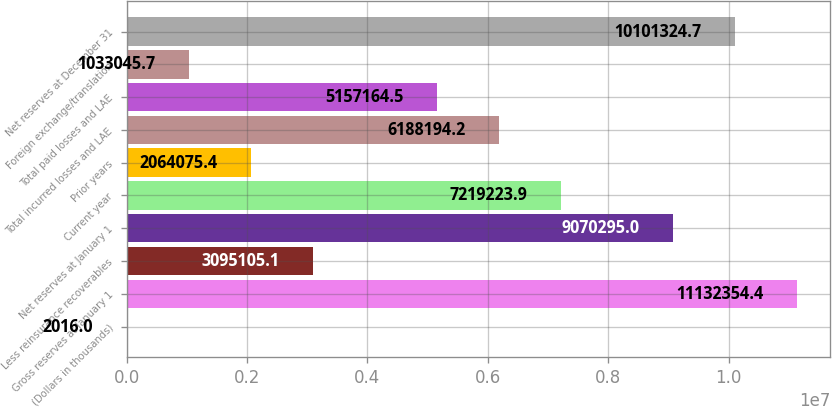Convert chart to OTSL. <chart><loc_0><loc_0><loc_500><loc_500><bar_chart><fcel>(Dollars in thousands)<fcel>Gross reserves at January 1<fcel>Less reinsurance recoverables<fcel>Net reserves at January 1<fcel>Current year<fcel>Prior years<fcel>Total incurred losses and LAE<fcel>Total paid losses and LAE<fcel>Foreign exchange/translation<fcel>Net reserves at December 31<nl><fcel>2016<fcel>1.11324e+07<fcel>3.09511e+06<fcel>9.0703e+06<fcel>7.21922e+06<fcel>2.06408e+06<fcel>6.18819e+06<fcel>5.15716e+06<fcel>1.03305e+06<fcel>1.01013e+07<nl></chart> 